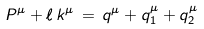<formula> <loc_0><loc_0><loc_500><loc_500>P ^ { \mu } + \ell \, k ^ { \mu } \, = \, q ^ { \mu } + q _ { 1 } ^ { \mu } + q _ { 2 } ^ { \mu }</formula> 